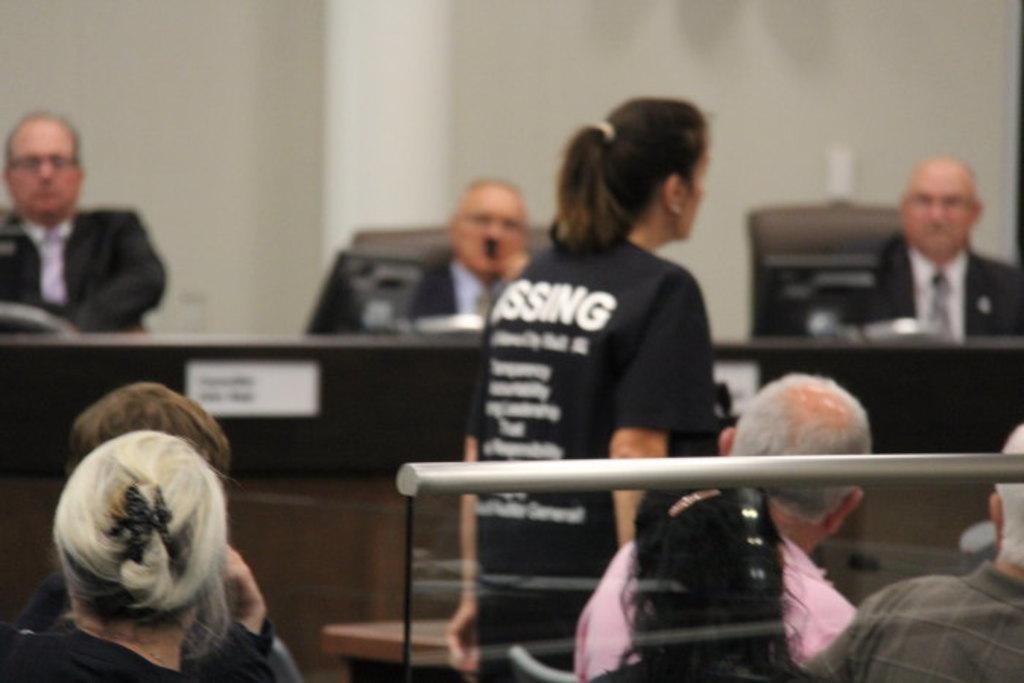Could you give a brief overview of what you see in this image? In the image it looks like some office, some people were sitting on the chairs and three men were sitting in front of the systems and there is a woman walking in between the area. 